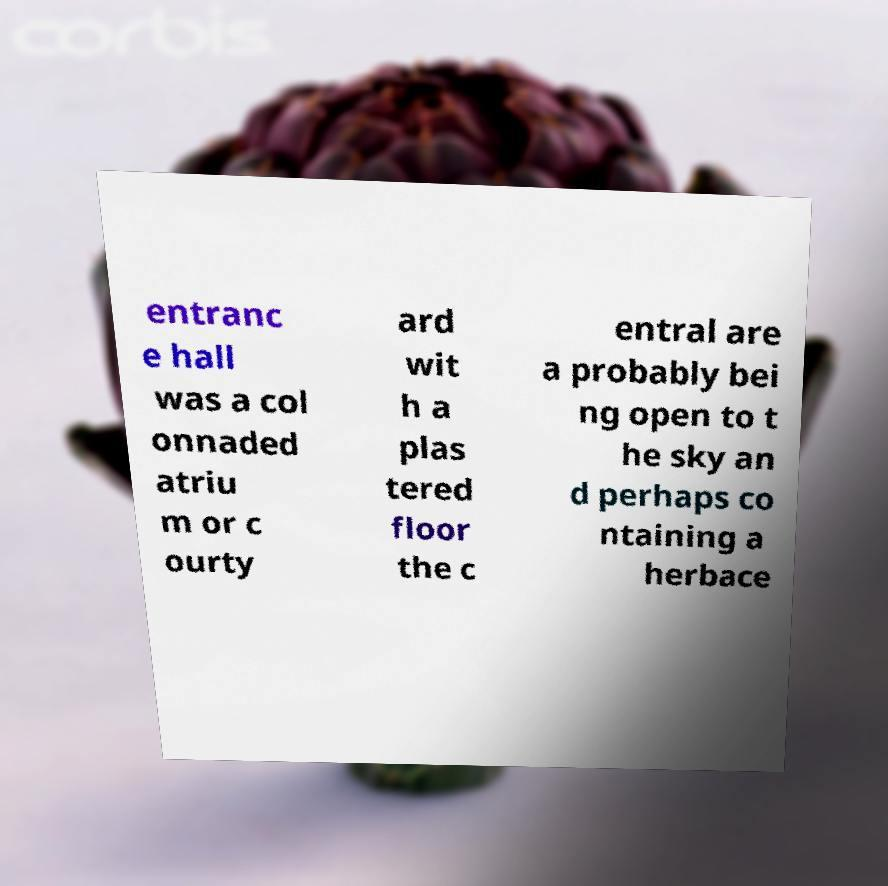Could you extract and type out the text from this image? entranc e hall was a col onnaded atriu m or c ourty ard wit h a plas tered floor the c entral are a probably bei ng open to t he sky an d perhaps co ntaining a herbace 